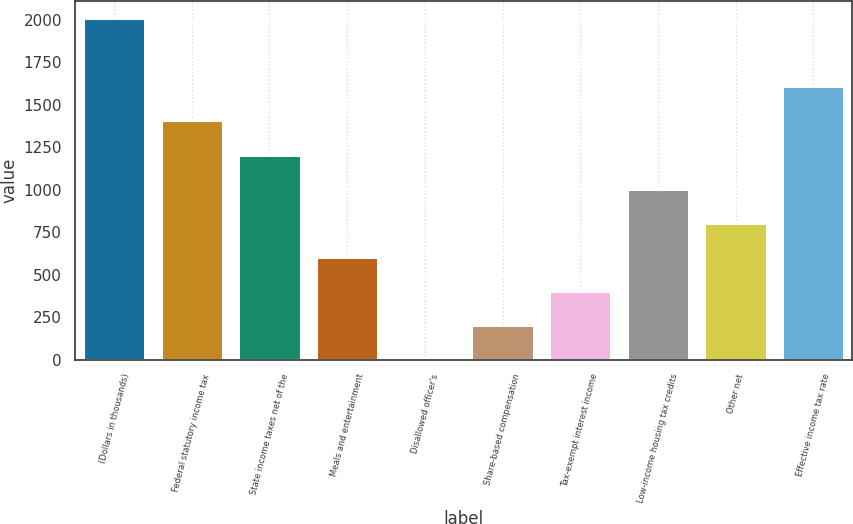Convert chart to OTSL. <chart><loc_0><loc_0><loc_500><loc_500><bar_chart><fcel>(Dollars in thousands)<fcel>Federal statutory income tax<fcel>State income taxes net of the<fcel>Meals and entertainment<fcel>Disallowed officer's<fcel>Share-based compensation<fcel>Tax-exempt interest income<fcel>Low-income housing tax credits<fcel>Other net<fcel>Effective income tax rate<nl><fcel>2012<fcel>1408.43<fcel>1207.24<fcel>603.67<fcel>0.1<fcel>201.29<fcel>402.48<fcel>1006.05<fcel>804.86<fcel>1609.62<nl></chart> 